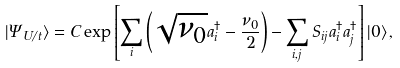Convert formula to latex. <formula><loc_0><loc_0><loc_500><loc_500>| \Psi _ { U / t } \rangle = C \exp \left [ \sum _ { i } \left ( \sqrt { \nu _ { 0 } } a _ { i } ^ { \dagger } - \frac { \nu _ { 0 } } { 2 } \right ) - \sum _ { i , j } S _ { i j } a ^ { \dagger } _ { i } a ^ { \dagger } _ { j } \right ] | 0 \rangle \, ,</formula> 